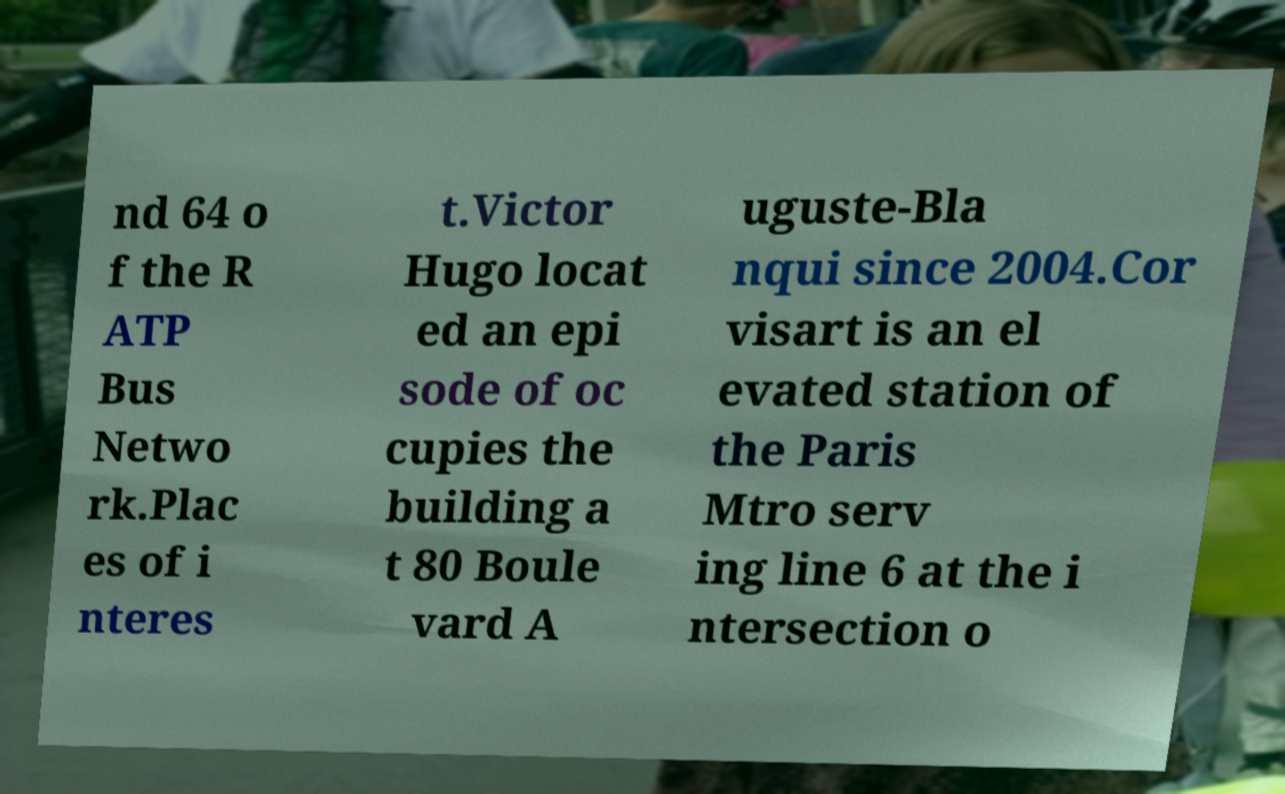Can you read and provide the text displayed in the image?This photo seems to have some interesting text. Can you extract and type it out for me? nd 64 o f the R ATP Bus Netwo rk.Plac es of i nteres t.Victor Hugo locat ed an epi sode of oc cupies the building a t 80 Boule vard A uguste-Bla nqui since 2004.Cor visart is an el evated station of the Paris Mtro serv ing line 6 at the i ntersection o 